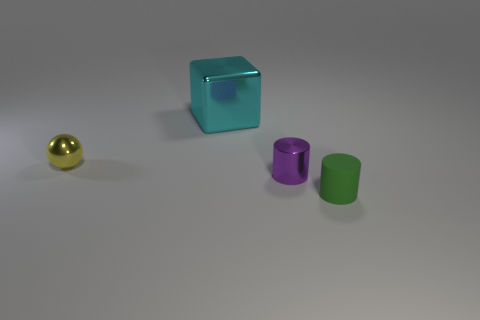Can you describe the lighting conditions in the scene and how they contribute to the ambiance? The lighting in the scene is soft and diffused, with shadows indicating an overhead light source. This creates a calm and neutral ambiance, focusing attention on the objects without strong emotional undertones. 